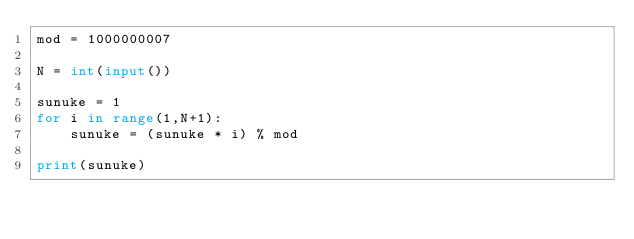<code> <loc_0><loc_0><loc_500><loc_500><_Python_>mod = 1000000007

N = int(input())

sunuke = 1
for i in range(1,N+1):
    sunuke = (sunuke * i) % mod
    
print(sunuke)</code> 